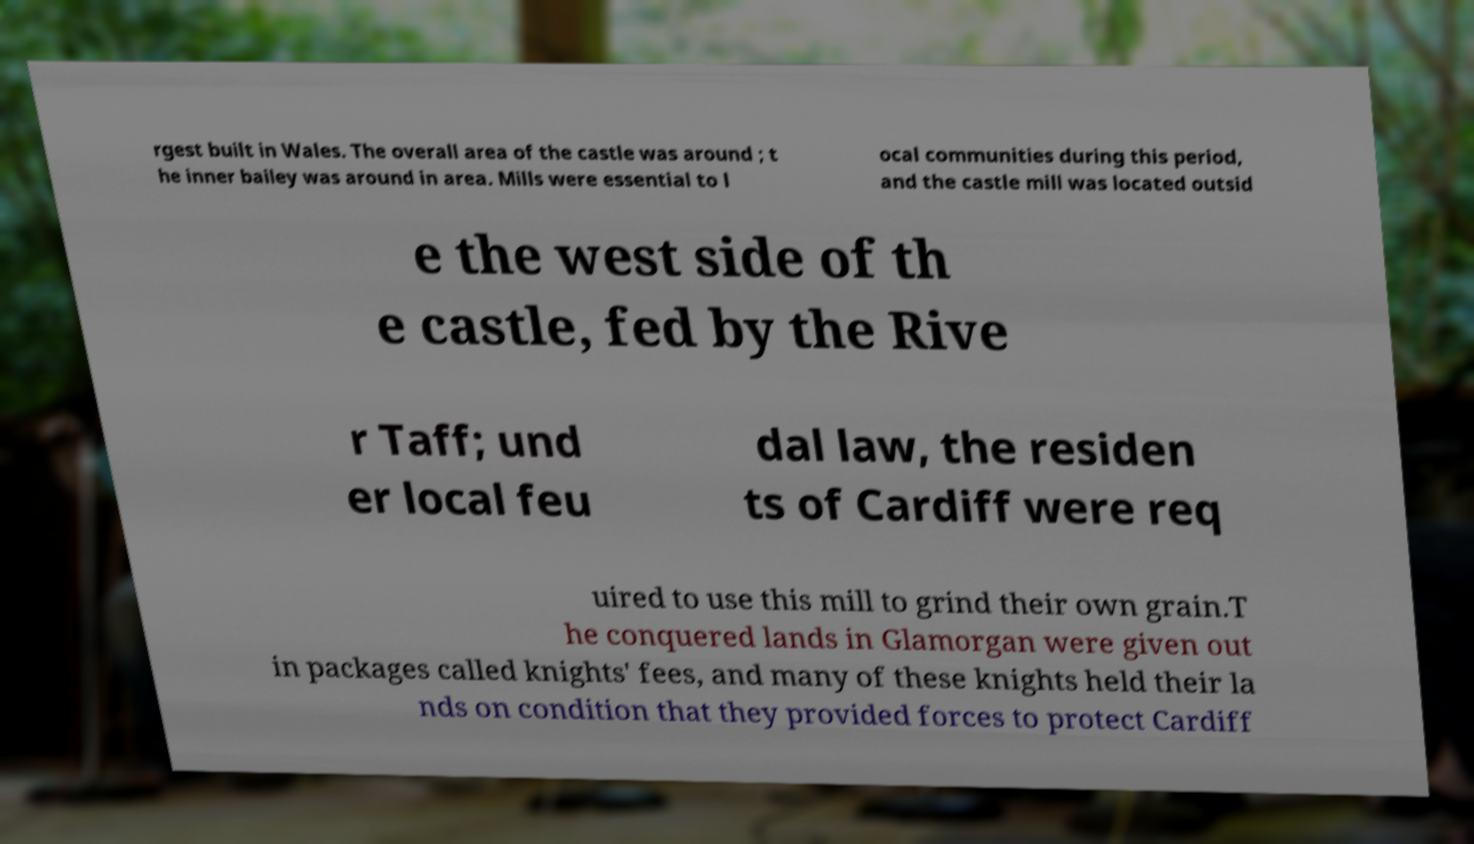Can you read and provide the text displayed in the image?This photo seems to have some interesting text. Can you extract and type it out for me? rgest built in Wales. The overall area of the castle was around ; t he inner bailey was around in area. Mills were essential to l ocal communities during this period, and the castle mill was located outsid e the west side of th e castle, fed by the Rive r Taff; und er local feu dal law, the residen ts of Cardiff were req uired to use this mill to grind their own grain.T he conquered lands in Glamorgan were given out in packages called knights' fees, and many of these knights held their la nds on condition that they provided forces to protect Cardiff 